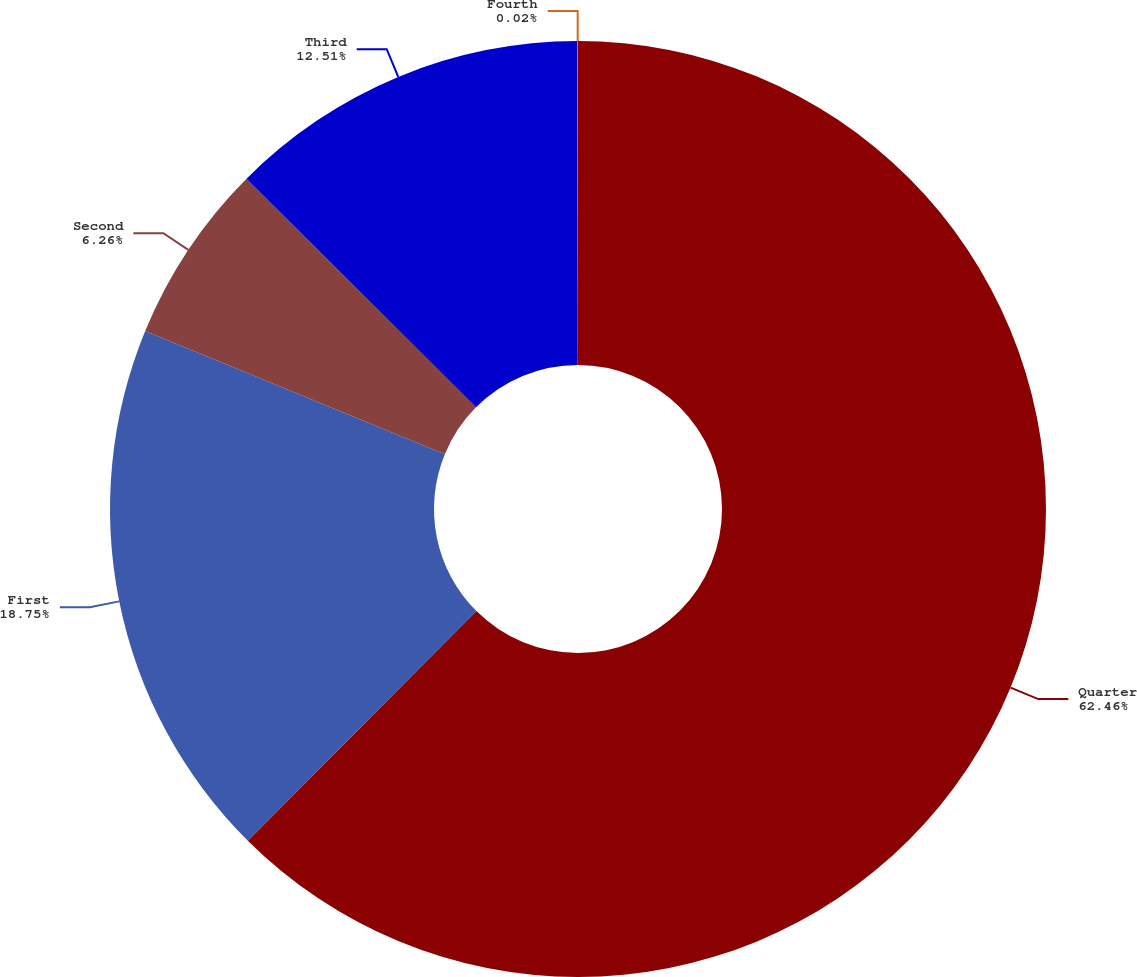Convert chart to OTSL. <chart><loc_0><loc_0><loc_500><loc_500><pie_chart><fcel>Quarter<fcel>First<fcel>Second<fcel>Third<fcel>Fourth<nl><fcel>62.47%<fcel>18.75%<fcel>6.26%<fcel>12.51%<fcel>0.02%<nl></chart> 